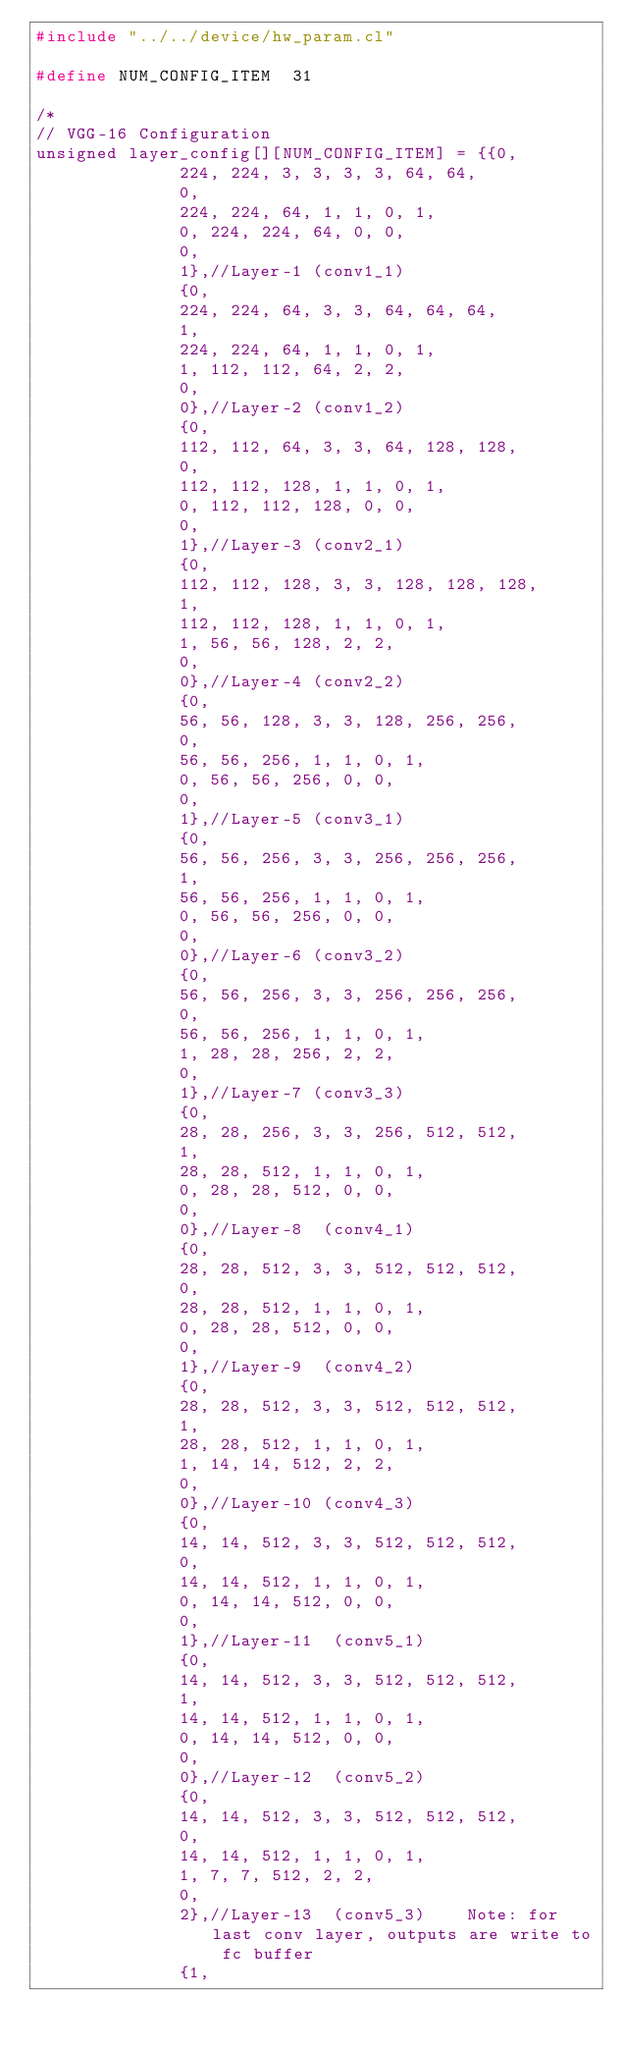Convert code to text. <code><loc_0><loc_0><loc_500><loc_500><_C_>#include "../../device/hw_param.cl"

#define NUM_CONFIG_ITEM  31

/*
// VGG-16 Configuration
unsigned layer_config[][NUM_CONFIG_ITEM] = {{0,
							224, 224, 3, 3, 3, 3, 64, 64,
							0,
							224, 224, 64, 1, 1, 0, 1,
							0, 224, 224, 64, 0, 0,
							0,
							1},//Layer-1 (conv1_1)
							{0,
							224, 224, 64, 3, 3, 64, 64, 64,
							1,
							224, 224, 64, 1, 1, 0, 1,
							1, 112, 112, 64, 2, 2,
							0,
							0},//Layer-2 (conv1_2)
							{0,
							112, 112, 64, 3, 3, 64, 128, 128,
							0,
							112, 112, 128, 1, 1, 0, 1,
							0, 112, 112, 128, 0, 0,
							0,
							1},//Layer-3 (conv2_1)
							{0,
							112, 112, 128, 3, 3, 128, 128, 128,
							1,
							112, 112, 128, 1, 1, 0, 1,
							1, 56, 56, 128, 2, 2,
							0,
							0},//Layer-4 (conv2_2)
							{0,
							56, 56, 128, 3, 3, 128, 256, 256,
							0,
							56, 56, 256, 1, 1, 0, 1,
							0, 56, 56, 256, 0, 0,
							0,
							1},//Layer-5 (conv3_1)
							{0,
							56, 56, 256, 3, 3, 256, 256, 256,
							1,
							56, 56, 256, 1, 1, 0, 1,
							0, 56, 56, 256, 0, 0,
							0,
							0},//Layer-6 (conv3_2)
							{0,
							56, 56, 256, 3, 3, 256, 256, 256,
							0,
							56, 56, 256, 1, 1, 0, 1,
							1, 28, 28, 256, 2, 2,
							0,
							1},//Layer-7 (conv3_3)
							{0,
							28, 28, 256, 3, 3, 256, 512, 512,
							1,
							28, 28, 512, 1, 1, 0, 1,
							0, 28, 28, 512, 0, 0,
							0,
							0},//Layer-8  (conv4_1)
							{0,
							28, 28, 512, 3, 3, 512, 512, 512,
							0,
							28, 28, 512, 1, 1, 0, 1,
							0, 28, 28, 512, 0, 0,
							0,
							1},//Layer-9  (conv4_2)
							{0,
							28, 28, 512, 3, 3, 512, 512, 512,
							1,
							28, 28, 512, 1, 1, 0, 1,
							1, 14, 14, 512, 2, 2,
							0,
							0},//Layer-10 (conv4_3)
							{0,
							14, 14, 512, 3, 3, 512, 512, 512,
							0,
							14, 14, 512, 1, 1, 0, 1,
							0, 14, 14, 512, 0, 0,
							0,
							1},//Layer-11  (conv5_1)
							{0,
							14, 14, 512, 3, 3, 512, 512, 512,
							1,
							14, 14, 512, 1, 1, 0, 1,
							0, 14, 14, 512, 0, 0,
							0,
							0},//Layer-12  (conv5_2)
							{0,
							14, 14, 512, 3, 3, 512, 512, 512,
							0,
							14, 14, 512, 1, 1, 0, 1,
							1, 7, 7, 512, 2, 2,
							0,
							2},//Layer-13  (conv5_3)    Note: for last conv layer, outputs are write to fc buffer
							{1,</code> 